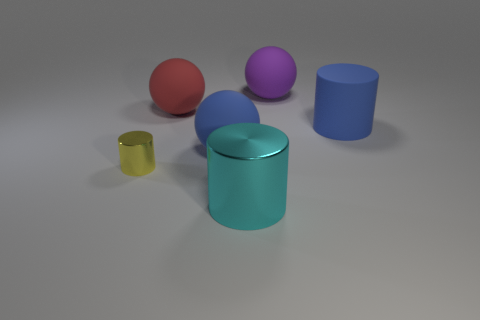Add 3 tiny red cubes. How many objects exist? 9 Add 1 blue things. How many blue things exist? 3 Subtract 0 purple cylinders. How many objects are left? 6 Subtract all cyan balls. Subtract all large red matte spheres. How many objects are left? 5 Add 2 spheres. How many spheres are left? 5 